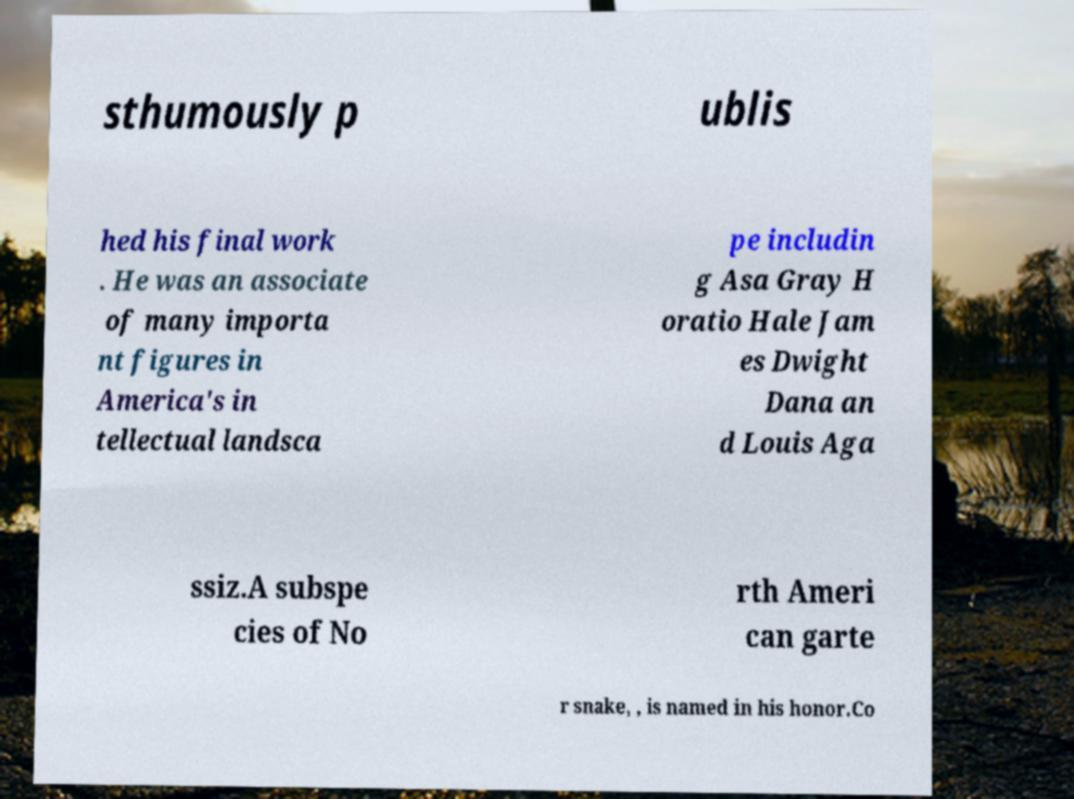Could you extract and type out the text from this image? sthumously p ublis hed his final work . He was an associate of many importa nt figures in America's in tellectual landsca pe includin g Asa Gray H oratio Hale Jam es Dwight Dana an d Louis Aga ssiz.A subspe cies of No rth Ameri can garte r snake, , is named in his honor.Co 